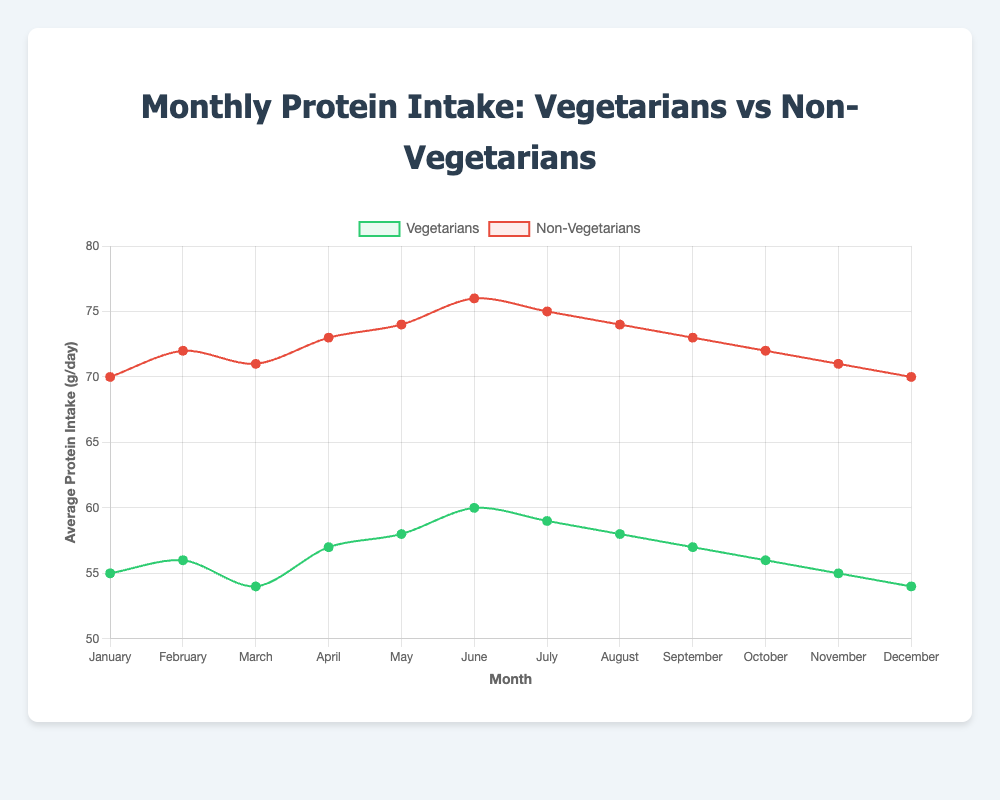How does the average protein intake of non-vegetarians compare to vegetarians in June? In June, the data shows non-vegetarians have an average protein intake of 76 g/day, whereas vegetarians have an average of 60 g/day. Comparing these values, non-vegetarians have a higher protein intake.
Answer: Non-vegetarians have a higher protein intake in June What's the difference in average protein intake between vegetarians and non-vegetarians in December? In December, vegetarians have an average protein intake of 54 g/day, and non-vegetarians have 70 g/day. The difference is 70 - 54 = 16 g/day.
Answer: 16 g/day What is the average protein intake over the year for vegetarians? Sum the monthly average protein intake values for vegetarians (55 + 56 + 54 + 57 + 58 + 60 + 59 + 58 + 57 + 56 + 55 + 54 = 679). There are 12 months, so the average is 679 / 12 ≈ 56.58 g/day.
Answer: 56.58 g/day In which month do non-vegetarians have the highest average protein intake, and what is the value? Look at the plot for the highest peak in the red line representing non-vegetarians. The highest value is in June with an average protein intake of 76 g/day.
Answer: June, 76 g/day What's the overall trend in protein intake for vegetarians from January to December? Observing the green line, vegetarians start at 55 g/day in January and generally fluctuate slightly with small peaks and dips, ending at 54 g/day in December. The overall trend is slightly downward.
Answer: Slightly downward By how much does the average protein intake of non-vegetarians reduce from July to December? The protein intake for non-vegetarians in July is 75 g/day and in December is 70 g/day. The reduction is 75 - 70 = 5 g/day.
Answer: 5 g/day During which months do vegetarians have a higher average protein intake than the previous month? Identify the months where the green line rises compared to the previous month. This happens from January to February (55 to 56), March to April (54 to 57), April to May (57 to 58), and May to June (58 to 60).
Answer: February, April, May, June Compare the average protein intake of vegetarians and non-vegetarians in August. In August, vegetarians have an average protein intake of 58 g/day and non-vegetarians have 74 g/day. Comparing these values, non-vegetarians have a higher intake.
Answer: Non-vegetarians have a higher intake What month shows the biggest difference in average protein intake between vegetarians and non-vegetarians? Calculate the differences for each month, the biggest difference is when non-vegetarians have 76 g/day and vegetarians have 60 g/day in June. The difference is 16 g/day.
Answer: June What is the range of average protein intake for non-vegetarians throughout the year? Find the minimum and maximum values for non-vegetarians. The minimum is 70 g/day (January and December), and the maximum is 76 g/day (June). The range is 76 - 70 = 6 g/day.
Answer: 6 g/day 